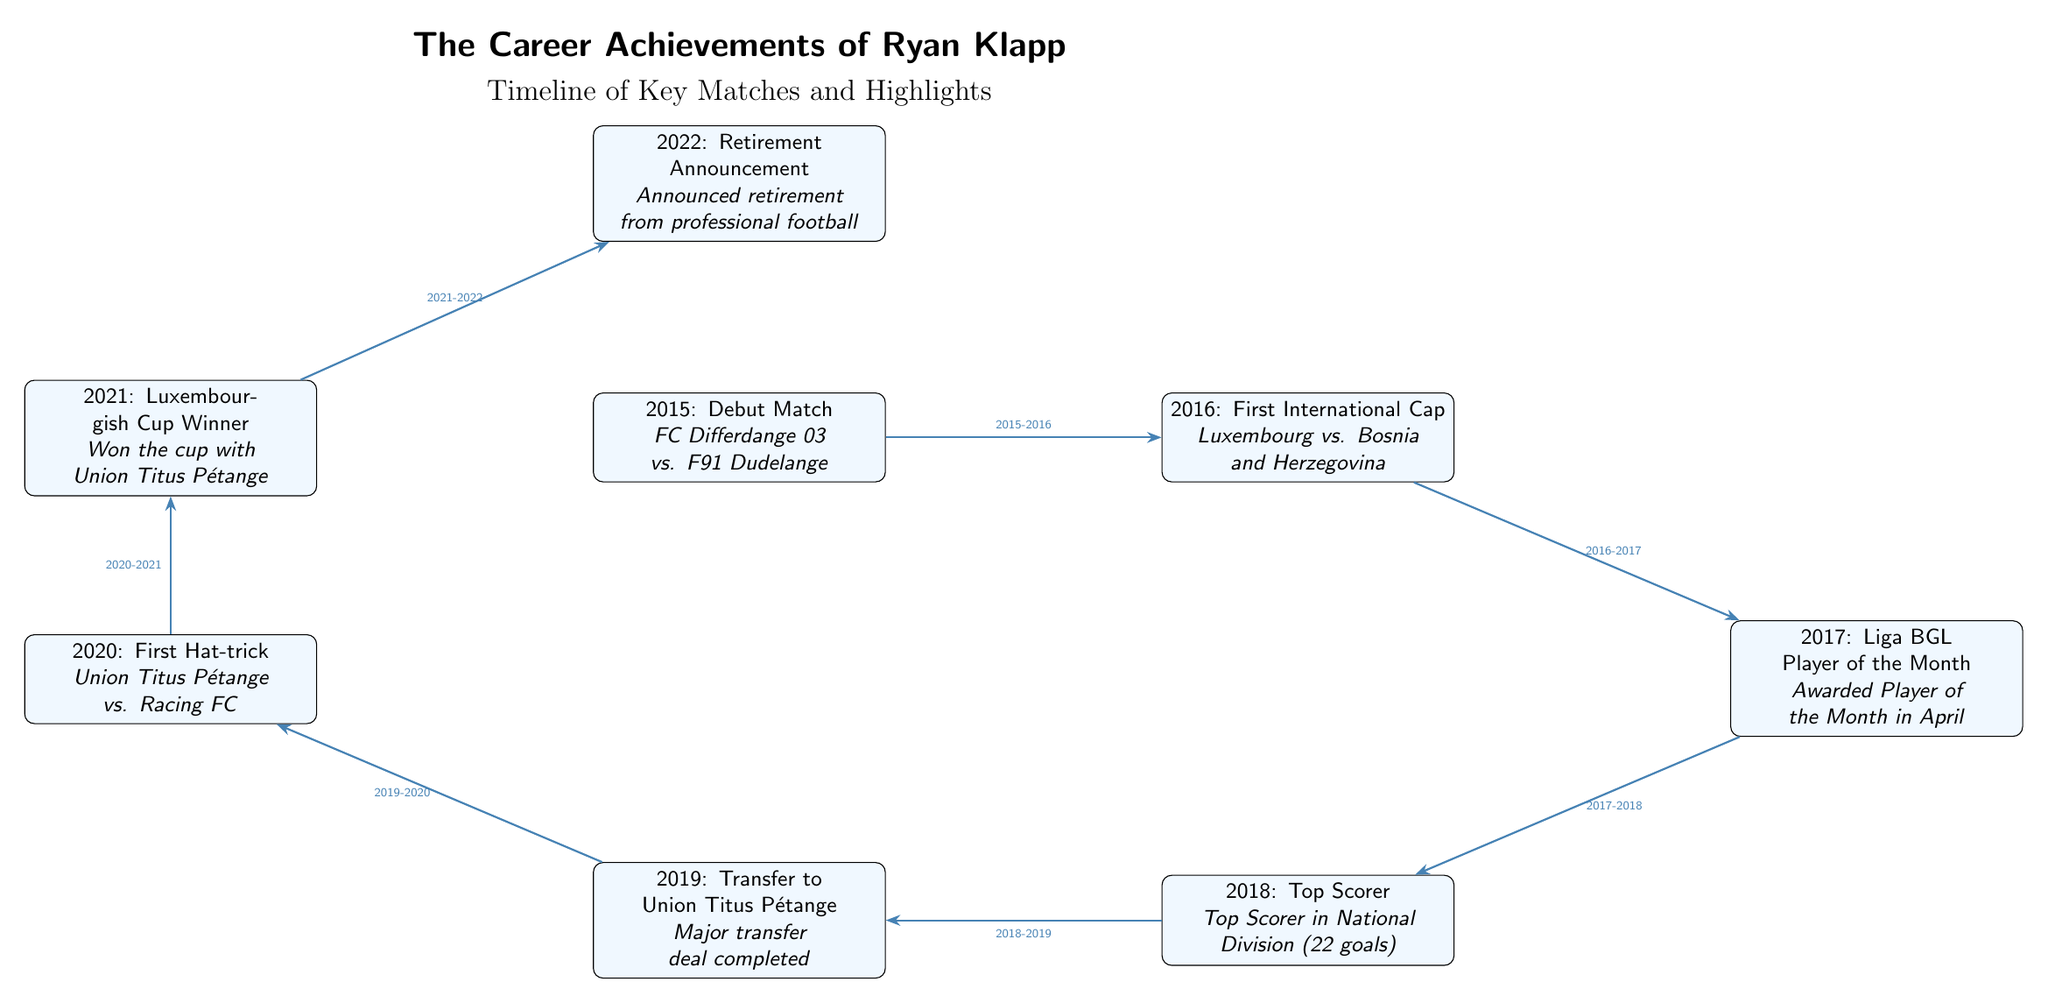What year did Ryan Klapp make his debut match? The diagram states that Ryan Klapp made his debut match in 2015, as indicated in the first node.
Answer: 2015 What accomplishment did Ryan Klapp achieve in 2018? According to the node for 2018, he was the Top Scorer in the National Division with 22 goals.
Answer: Top Scorer What was the result of Ryan Klapp's first match for the national team? The second node mentions his first international cap was against Bosnia and Herzegovina in 2016, but it does not specify the outcome of the match. Thus this question cannot be answered from the diagram.
Answer: Not specified How many years did Ryan Klapp play before announcing his retirement? He debuted in 2015 and announced his retirement in 2022, which spans 7 years. Therefore, the calculation is 2022 - 2015 = 7.
Answer: 7 Which award did he receive in April 2017? The diagram notes that he was awarded the Liga BGL Player of the Month in April, which is detailed in the node for 2017.
Answer: Player of the Month What is the sequence of Ryan Klapp's career events from 2015 to 2022? Based on the arrows connecting the nodes, the sequence goes from Debut Match in 2015, to First International Cap in 2016, Player of the Month in 2017, Top Scorer in 2018, Transfer to Union Titus Pétange in 2019, First Hat-trick in 2020, Luxembourgish Cup Winner in 2021, and Retirement Announcement in 2022.
Answer: Debut Match, First International Cap, Player of the Month, Top Scorer, Transfer, First Hat-trick, Cup Winner, Retirement Which year did Ryan Klapp achieve his first hat-trick? The hat-trick achievement is marked in the 2020 node within the timeline, showing that it occurred that year.
Answer: 2020 What team did Ryan Klapp join in 2019? The diagram notes in the 2019 node that he transferred to Union Titus Pétange.
Answer: Union Titus Pétange How many total key events are listed in the timeline? There are 8 nodes present in the diagram, each symbolizing a key event in Ryan Klapp's career from 2015 to 2022.
Answer: 8 